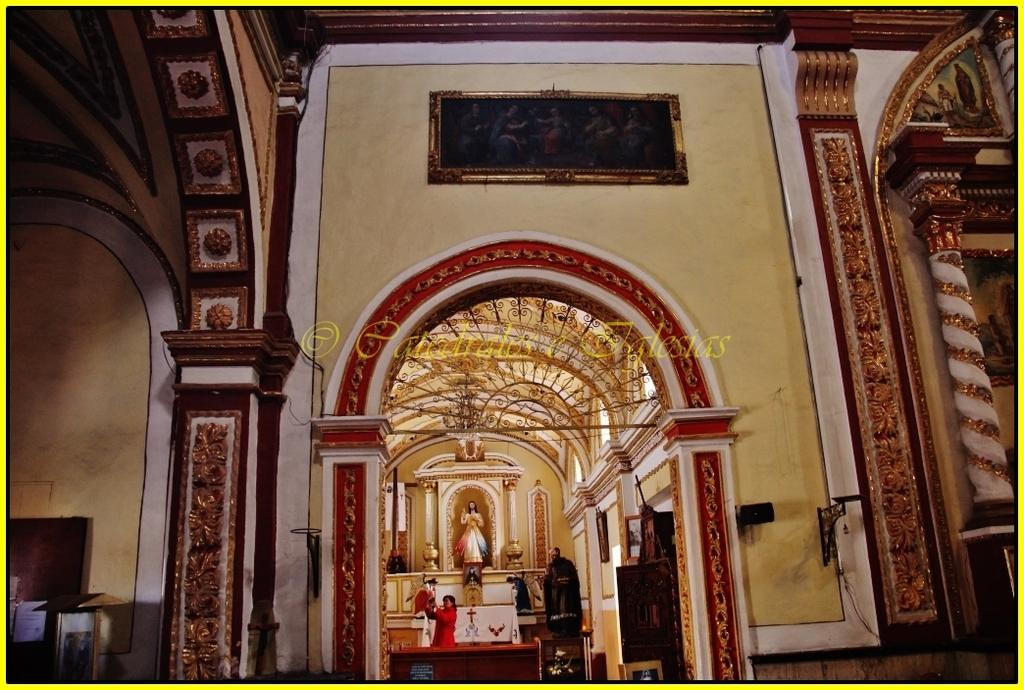What type of objects are depicted in the image? There are statues of people in the image. What else can be seen in the image besides the statues? There is a frame and an internal structure of a building in the image. Is there any additional information or marking in the image? Yes, there is a watermark in the image. What decision was made by the air in the image? There is no air or decision-making process depicted in the image; it features statues, a frame, an internal structure of a building, and a watermark. 